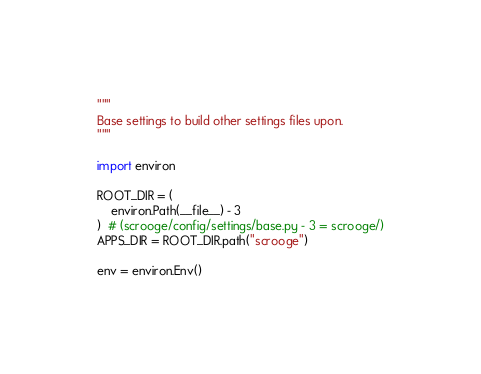Convert code to text. <code><loc_0><loc_0><loc_500><loc_500><_Python_>"""
Base settings to build other settings files upon.
"""

import environ

ROOT_DIR = (
    environ.Path(__file__) - 3
)  # (scrooge/config/settings/base.py - 3 = scrooge/)
APPS_DIR = ROOT_DIR.path("scrooge")

env = environ.Env()
</code> 